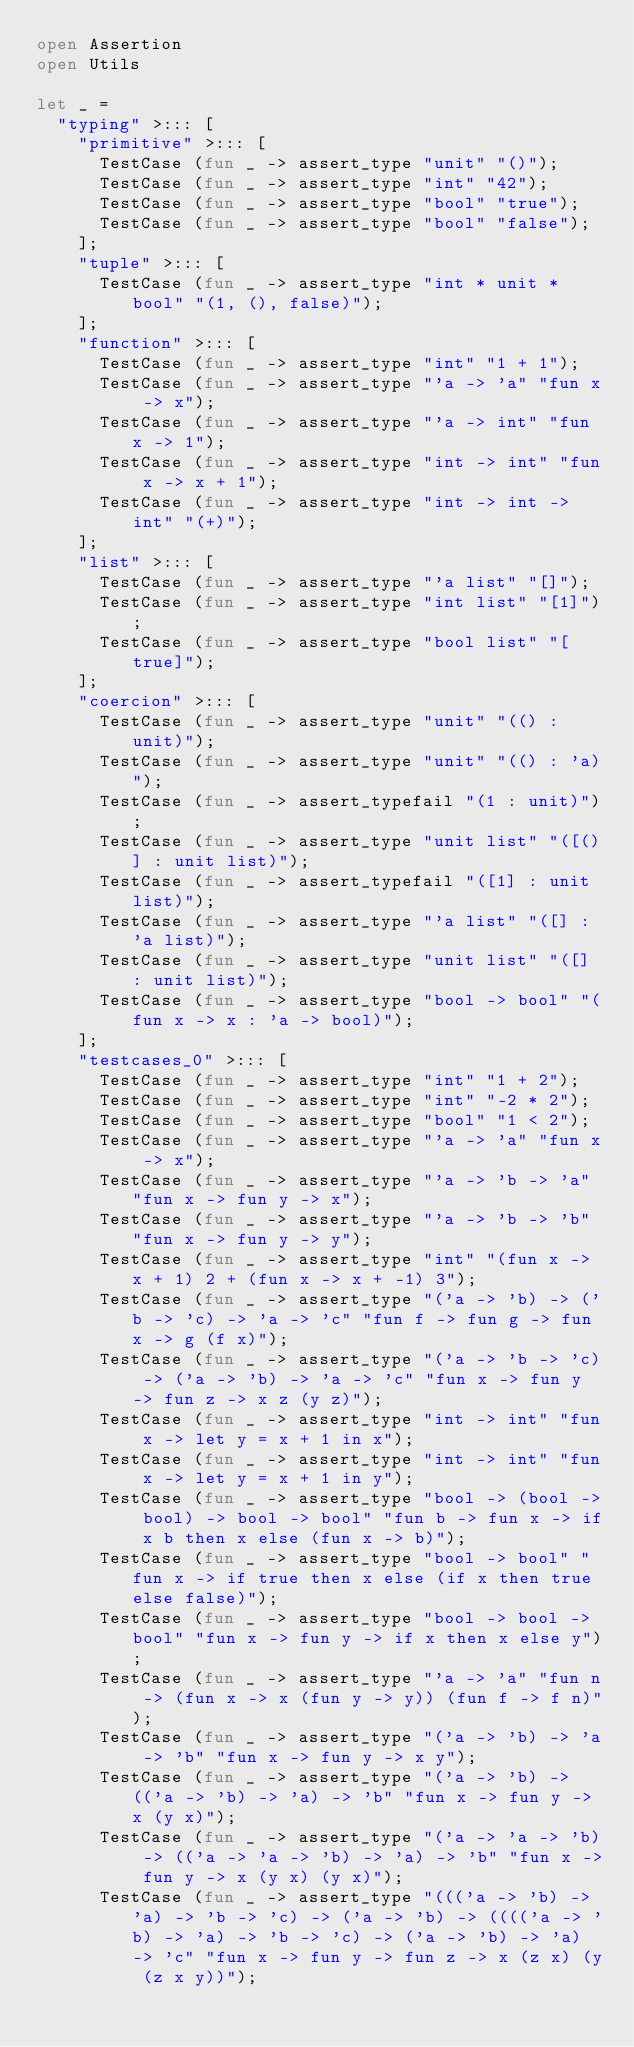Convert code to text. <code><loc_0><loc_0><loc_500><loc_500><_OCaml_>open Assertion
open Utils

let _ =
  "typing" >::: [
    "primitive" >::: [
      TestCase (fun _ -> assert_type "unit" "()");
      TestCase (fun _ -> assert_type "int" "42");
      TestCase (fun _ -> assert_type "bool" "true");
      TestCase (fun _ -> assert_type "bool" "false");
    ];
    "tuple" >::: [
      TestCase (fun _ -> assert_type "int * unit * bool" "(1, (), false)");
    ];
    "function" >::: [
      TestCase (fun _ -> assert_type "int" "1 + 1");
      TestCase (fun _ -> assert_type "'a -> 'a" "fun x -> x");
      TestCase (fun _ -> assert_type "'a -> int" "fun x -> 1");
      TestCase (fun _ -> assert_type "int -> int" "fun x -> x + 1");
      TestCase (fun _ -> assert_type "int -> int -> int" "(+)");
    ];
    "list" >::: [
      TestCase (fun _ -> assert_type "'a list" "[]");
      TestCase (fun _ -> assert_type "int list" "[1]");
      TestCase (fun _ -> assert_type "bool list" "[true]");
    ];
    "coercion" >::: [
      TestCase (fun _ -> assert_type "unit" "(() : unit)");
      TestCase (fun _ -> assert_type "unit" "(() : 'a)");
      TestCase (fun _ -> assert_typefail "(1 : unit)");
      TestCase (fun _ -> assert_type "unit list" "([()] : unit list)");
      TestCase (fun _ -> assert_typefail "([1] : unit list)");
      TestCase (fun _ -> assert_type "'a list" "([] : 'a list)");
      TestCase (fun _ -> assert_type "unit list" "([] : unit list)");
      TestCase (fun _ -> assert_type "bool -> bool" "(fun x -> x : 'a -> bool)");
    ];
    "testcases_0" >::: [
      TestCase (fun _ -> assert_type "int" "1 + 2");
      TestCase (fun _ -> assert_type "int" "-2 * 2");
      TestCase (fun _ -> assert_type "bool" "1 < 2");
      TestCase (fun _ -> assert_type "'a -> 'a" "fun x -> x");
      TestCase (fun _ -> assert_type "'a -> 'b -> 'a" "fun x -> fun y -> x");
      TestCase (fun _ -> assert_type "'a -> 'b -> 'b" "fun x -> fun y -> y");
      TestCase (fun _ -> assert_type "int" "(fun x -> x + 1) 2 + (fun x -> x + -1) 3");
      TestCase (fun _ -> assert_type "('a -> 'b) -> ('b -> 'c) -> 'a -> 'c" "fun f -> fun g -> fun x -> g (f x)");
      TestCase (fun _ -> assert_type "('a -> 'b -> 'c) -> ('a -> 'b) -> 'a -> 'c" "fun x -> fun y -> fun z -> x z (y z)");
      TestCase (fun _ -> assert_type "int -> int" "fun x -> let y = x + 1 in x");
      TestCase (fun _ -> assert_type "int -> int" "fun x -> let y = x + 1 in y");
      TestCase (fun _ -> assert_type "bool -> (bool -> bool) -> bool -> bool" "fun b -> fun x -> if x b then x else (fun x -> b)");
      TestCase (fun _ -> assert_type "bool -> bool" "fun x -> if true then x else (if x then true else false)");
      TestCase (fun _ -> assert_type "bool -> bool -> bool" "fun x -> fun y -> if x then x else y");
      TestCase (fun _ -> assert_type "'a -> 'a" "fun n -> (fun x -> x (fun y -> y)) (fun f -> f n)");
      TestCase (fun _ -> assert_type "('a -> 'b) -> 'a -> 'b" "fun x -> fun y -> x y");
      TestCase (fun _ -> assert_type "('a -> 'b) -> (('a -> 'b) -> 'a) -> 'b" "fun x -> fun y -> x (y x)");
      TestCase (fun _ -> assert_type "('a -> 'a -> 'b) -> (('a -> 'a -> 'b) -> 'a) -> 'b" "fun x -> fun y -> x (y x) (y x)");
      TestCase (fun _ -> assert_type "((('a -> 'b) -> 'a) -> 'b -> 'c) -> ('a -> 'b) -> (((('a -> 'b) -> 'a) -> 'b -> 'c) -> ('a -> 'b) -> 'a) -> 'c" "fun x -> fun y -> fun z -> x (z x) (y (z x y))");</code> 